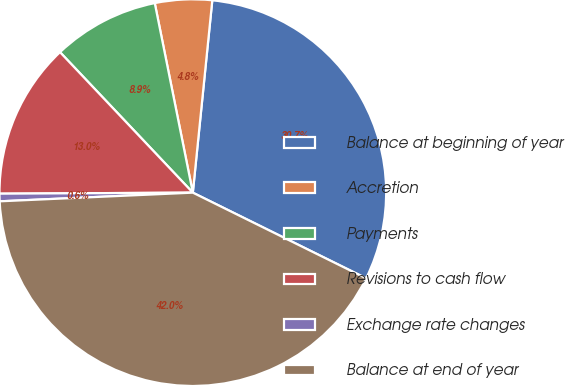Convert chart to OTSL. <chart><loc_0><loc_0><loc_500><loc_500><pie_chart><fcel>Balance at beginning of year<fcel>Accretion<fcel>Payments<fcel>Revisions to cash flow<fcel>Exchange rate changes<fcel>Balance at end of year<nl><fcel>30.7%<fcel>4.76%<fcel>8.9%<fcel>13.03%<fcel>0.63%<fcel>41.98%<nl></chart> 